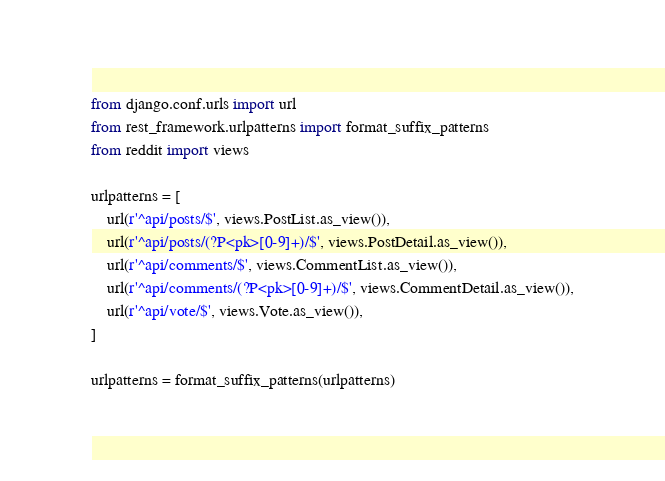Convert code to text. <code><loc_0><loc_0><loc_500><loc_500><_Python_>from django.conf.urls import url
from rest_framework.urlpatterns import format_suffix_patterns
from reddit import views

urlpatterns = [
    url(r'^api/posts/$', views.PostList.as_view()),
    url(r'^api/posts/(?P<pk>[0-9]+)/$', views.PostDetail.as_view()),
    url(r'^api/comments/$', views.CommentList.as_view()),
    url(r'^api/comments/(?P<pk>[0-9]+)/$', views.CommentDetail.as_view()),
    url(r'^api/vote/$', views.Vote.as_view()),
]

urlpatterns = format_suffix_patterns(urlpatterns)</code> 